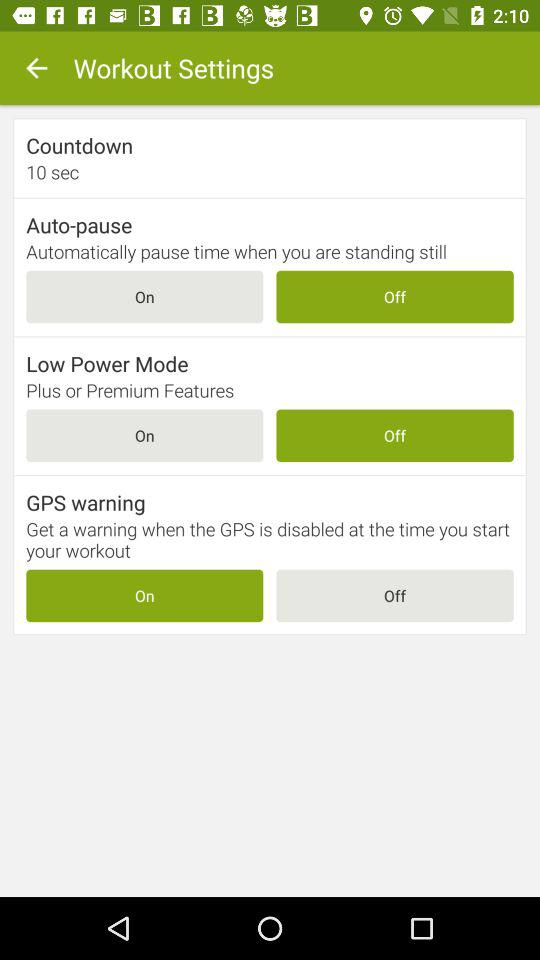What is the current status of the auto pause setting? The status is off. 